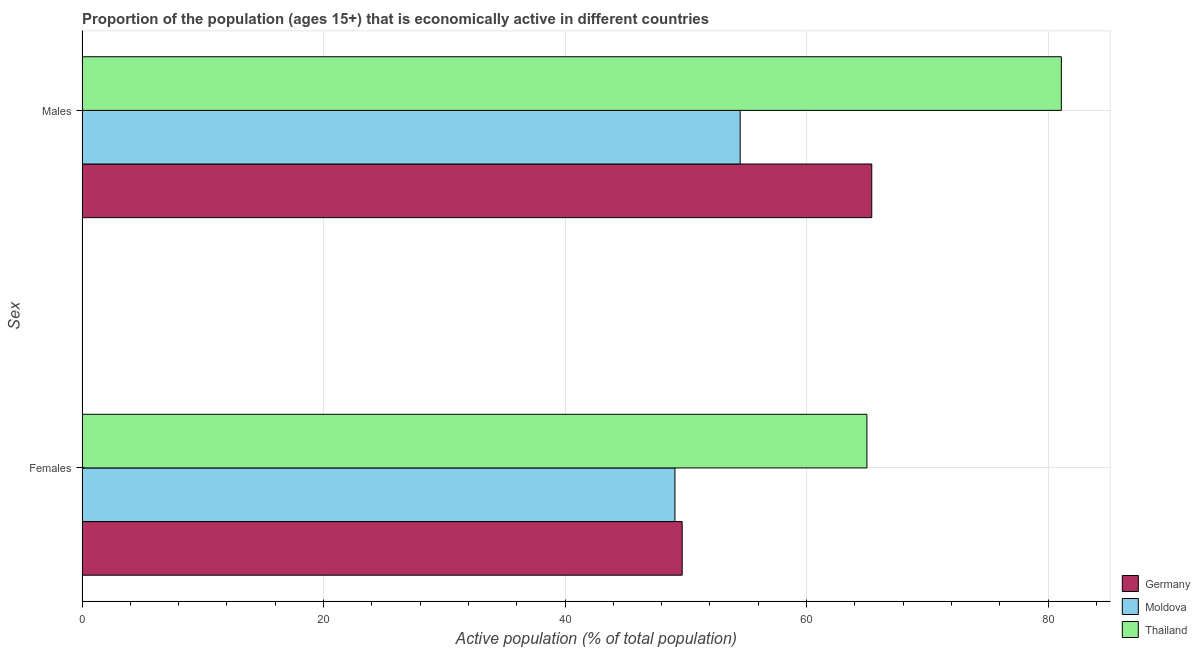How many groups of bars are there?
Your response must be concise. 2. Are the number of bars per tick equal to the number of legend labels?
Provide a short and direct response. Yes. Are the number of bars on each tick of the Y-axis equal?
Offer a terse response. Yes. How many bars are there on the 2nd tick from the top?
Your answer should be compact. 3. How many bars are there on the 2nd tick from the bottom?
Your response must be concise. 3. What is the label of the 1st group of bars from the top?
Your response must be concise. Males. What is the percentage of economically active female population in Germany?
Provide a short and direct response. 49.7. Across all countries, what is the maximum percentage of economically active male population?
Your answer should be very brief. 81.1. Across all countries, what is the minimum percentage of economically active female population?
Provide a succinct answer. 49.1. In which country was the percentage of economically active female population maximum?
Your answer should be very brief. Thailand. In which country was the percentage of economically active female population minimum?
Provide a short and direct response. Moldova. What is the total percentage of economically active male population in the graph?
Provide a succinct answer. 201. What is the difference between the percentage of economically active male population in Thailand and that in Germany?
Offer a very short reply. 15.7. What is the difference between the percentage of economically active female population in Moldova and the percentage of economically active male population in Thailand?
Offer a terse response. -32. What is the average percentage of economically active male population per country?
Make the answer very short. 67. What is the difference between the percentage of economically active female population and percentage of economically active male population in Thailand?
Offer a terse response. -16.1. What is the ratio of the percentage of economically active male population in Germany to that in Moldova?
Provide a short and direct response. 1.2. Is the percentage of economically active female population in Germany less than that in Moldova?
Your answer should be very brief. No. In how many countries, is the percentage of economically active female population greater than the average percentage of economically active female population taken over all countries?
Your answer should be compact. 1. What does the 1st bar from the top in Females represents?
Ensure brevity in your answer.  Thailand. What does the 3rd bar from the bottom in Females represents?
Your answer should be compact. Thailand. What is the difference between two consecutive major ticks on the X-axis?
Offer a terse response. 20. Are the values on the major ticks of X-axis written in scientific E-notation?
Give a very brief answer. No. Where does the legend appear in the graph?
Your answer should be very brief. Bottom right. What is the title of the graph?
Your answer should be very brief. Proportion of the population (ages 15+) that is economically active in different countries. What is the label or title of the X-axis?
Offer a terse response. Active population (% of total population). What is the label or title of the Y-axis?
Make the answer very short. Sex. What is the Active population (% of total population) in Germany in Females?
Provide a short and direct response. 49.7. What is the Active population (% of total population) of Moldova in Females?
Offer a very short reply. 49.1. What is the Active population (% of total population) in Thailand in Females?
Your answer should be compact. 65. What is the Active population (% of total population) of Germany in Males?
Offer a terse response. 65.4. What is the Active population (% of total population) of Moldova in Males?
Give a very brief answer. 54.5. What is the Active population (% of total population) in Thailand in Males?
Make the answer very short. 81.1. Across all Sex, what is the maximum Active population (% of total population) of Germany?
Your response must be concise. 65.4. Across all Sex, what is the maximum Active population (% of total population) of Moldova?
Make the answer very short. 54.5. Across all Sex, what is the maximum Active population (% of total population) in Thailand?
Offer a very short reply. 81.1. Across all Sex, what is the minimum Active population (% of total population) in Germany?
Your response must be concise. 49.7. Across all Sex, what is the minimum Active population (% of total population) of Moldova?
Ensure brevity in your answer.  49.1. What is the total Active population (% of total population) of Germany in the graph?
Your answer should be very brief. 115.1. What is the total Active population (% of total population) in Moldova in the graph?
Make the answer very short. 103.6. What is the total Active population (% of total population) in Thailand in the graph?
Your answer should be compact. 146.1. What is the difference between the Active population (% of total population) of Germany in Females and that in Males?
Your response must be concise. -15.7. What is the difference between the Active population (% of total population) in Moldova in Females and that in Males?
Your answer should be compact. -5.4. What is the difference between the Active population (% of total population) of Thailand in Females and that in Males?
Your answer should be very brief. -16.1. What is the difference between the Active population (% of total population) of Germany in Females and the Active population (% of total population) of Moldova in Males?
Your answer should be compact. -4.8. What is the difference between the Active population (% of total population) in Germany in Females and the Active population (% of total population) in Thailand in Males?
Your answer should be very brief. -31.4. What is the difference between the Active population (% of total population) in Moldova in Females and the Active population (% of total population) in Thailand in Males?
Your response must be concise. -32. What is the average Active population (% of total population) in Germany per Sex?
Provide a short and direct response. 57.55. What is the average Active population (% of total population) of Moldova per Sex?
Provide a succinct answer. 51.8. What is the average Active population (% of total population) of Thailand per Sex?
Your response must be concise. 73.05. What is the difference between the Active population (% of total population) in Germany and Active population (% of total population) in Moldova in Females?
Provide a succinct answer. 0.6. What is the difference between the Active population (% of total population) in Germany and Active population (% of total population) in Thailand in Females?
Make the answer very short. -15.3. What is the difference between the Active population (% of total population) of Moldova and Active population (% of total population) of Thailand in Females?
Ensure brevity in your answer.  -15.9. What is the difference between the Active population (% of total population) in Germany and Active population (% of total population) in Moldova in Males?
Offer a very short reply. 10.9. What is the difference between the Active population (% of total population) of Germany and Active population (% of total population) of Thailand in Males?
Give a very brief answer. -15.7. What is the difference between the Active population (% of total population) of Moldova and Active population (% of total population) of Thailand in Males?
Keep it short and to the point. -26.6. What is the ratio of the Active population (% of total population) of Germany in Females to that in Males?
Make the answer very short. 0.76. What is the ratio of the Active population (% of total population) of Moldova in Females to that in Males?
Offer a very short reply. 0.9. What is the ratio of the Active population (% of total population) in Thailand in Females to that in Males?
Keep it short and to the point. 0.8. What is the difference between the highest and the lowest Active population (% of total population) of Germany?
Provide a succinct answer. 15.7. What is the difference between the highest and the lowest Active population (% of total population) in Thailand?
Offer a terse response. 16.1. 